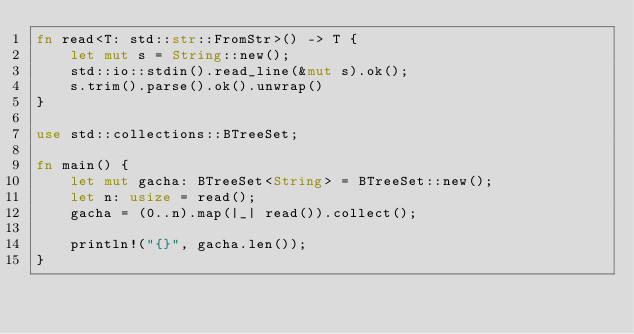Convert code to text. <code><loc_0><loc_0><loc_500><loc_500><_Rust_>fn read<T: std::str::FromStr>() -> T {
    let mut s = String::new();
    std::io::stdin().read_line(&mut s).ok();
    s.trim().parse().ok().unwrap()
}

use std::collections::BTreeSet;

fn main() {
    let mut gacha: BTreeSet<String> = BTreeSet::new();
    let n: usize = read();
    gacha = (0..n).map(|_| read()).collect();

    println!("{}", gacha.len());
}
</code> 